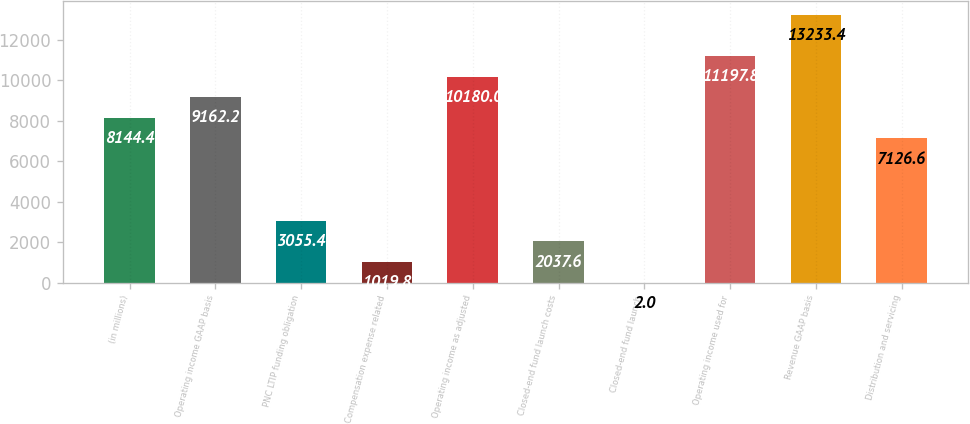<chart> <loc_0><loc_0><loc_500><loc_500><bar_chart><fcel>(in millions)<fcel>Operating income GAAP basis<fcel>PNC LTIP funding obligation<fcel>Compensation expense related<fcel>Operating income as adjusted<fcel>Closed-end fund launch costs<fcel>Closed-end fund launch<fcel>Operating income used for<fcel>Revenue GAAP basis<fcel>Distribution and servicing<nl><fcel>8144.4<fcel>9162.2<fcel>3055.4<fcel>1019.8<fcel>10180<fcel>2037.6<fcel>2<fcel>11197.8<fcel>13233.4<fcel>7126.6<nl></chart> 